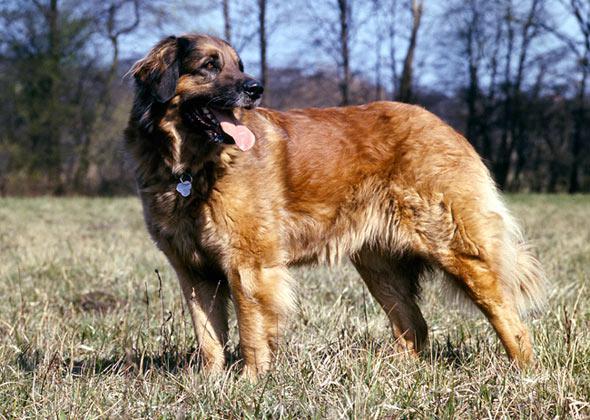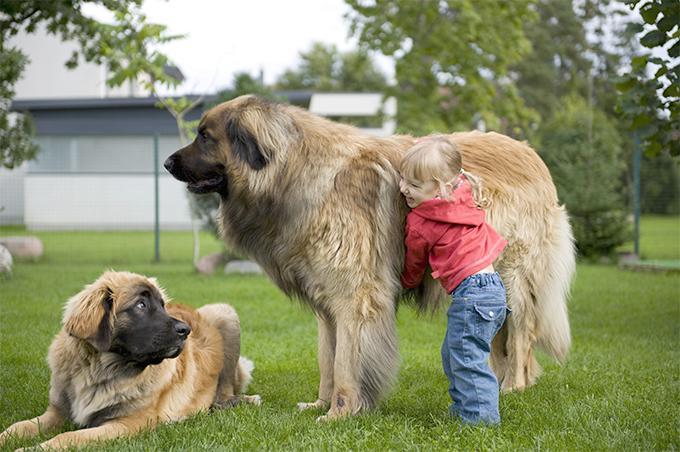The first image is the image on the left, the second image is the image on the right. Assess this claim about the two images: "One of the dogs has its belly on the ground.". Correct or not? Answer yes or no. Yes. 